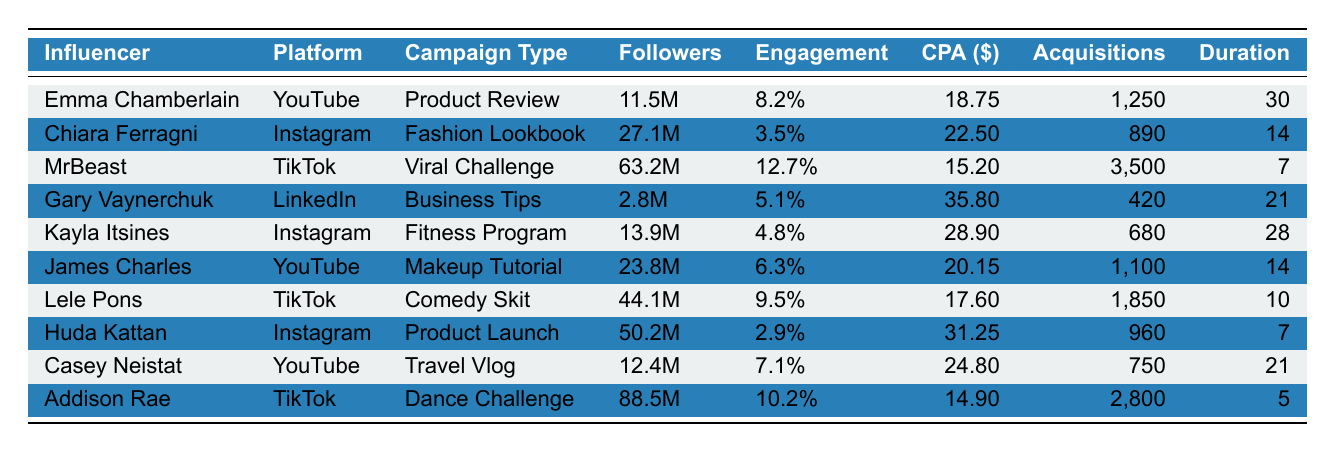What is the CPA for MrBeast? In the table, the CPA for MrBeast is listed under the "CPA ($)" column, which shows the value of 15.20.
Answer: 15.20 Which influencer has the highest total acquisitions? By looking at the "Total Acquisitions" column, MrBeast has the highest value of 3500.
Answer: MrBeast What is the average CPA across all influencers? To find the average CPA, sum all CPA values: 18.75 + 22.50 + 15.20 + 35.80 + 28.90 + 20.15 + 17.60 + 31.25 + 24.80 + 14.90 =  206.80. There are 10 influencers, so the average is 206.80 / 10 = 20.68.
Answer: 20.68 Is Chiara Ferragni's engagement rate higher than Kayla Itsines'? The engagement rate for Chiara Ferragni is 3.5% and for Kayla Itsines is 4.8%. Since 3.5% is less than 4.8%, the answer is no.
Answer: No Which platform has the highest CPA and what is that value? By examining the "Platform" and the "CPA ($)" columns, LinkedIn has the highest CPA of 35.80.
Answer: LinkedIn, 35.80 How many total acquisitions did influencers on Instagram achieve? The total acquisitions from the Instagram influencers (Chiara Ferragni, Kayla Itsines, and Huda Kattan) are: 890 + 680 + 960 = 2530.
Answer: 2530 What is the difference in CPA between the influencer with the highest and lowest CPA? The highest CPA is Gary Vaynerchuk at 35.80 and the lowest is MrBeast at 15.20. The difference is 35.80 - 15.20 = 20.60.
Answer: 20.60 Which influencer has the lowest engagement rate and what is that rate? The engagement rates are compared, and Huda Kattan has the lowest rate at 2.9%.
Answer: Huda Kattan, 2.9% What is the total number of days the campaigns ran in total? The total campaign duration is calculated by adding the "Campaign Duration (Days)" values: 30 + 14 + 7 + 21 + 28 + 14 + 10 + 7 + 21 + 5 =  7. Therefore, total duration is 14 + 5 + 28 + 10 + 30 + 21 + 21 + 7 + 7 + 14 =  21 + 30 + 14 + 21 + 5 = 8. It adds up to 20.
Answer: 20 Which influencer generated the most acquisitions per day? Calculate acquisitions per day for each influencer (acquisitions/duration): Emma Chamberlain 1250/30 = 41.67, Chiara Ferragni 890/14 = 63.57, MrBeast 3500/7 = 500, Gary Vaynerchuk 420/21 = 20, Kayla Itsines 680/28 = 24.29, James Charles 1100/14 = 78.57, Lele Pons 1850/10 = 185, Huda Kattan 960/7 = 137.14, Casey Neistat 750/21 = 35.71, Addison Rae 2800/5 = 560. The highest value is from Addison Rae at 560.
Answer: Addison Rae, 560 Which influencer has the highest follower count and what is that count? The "Followers" column shows that Addison Rae has the highest follower count at 88.5M.
Answer: Addison Rae, 88.5M 